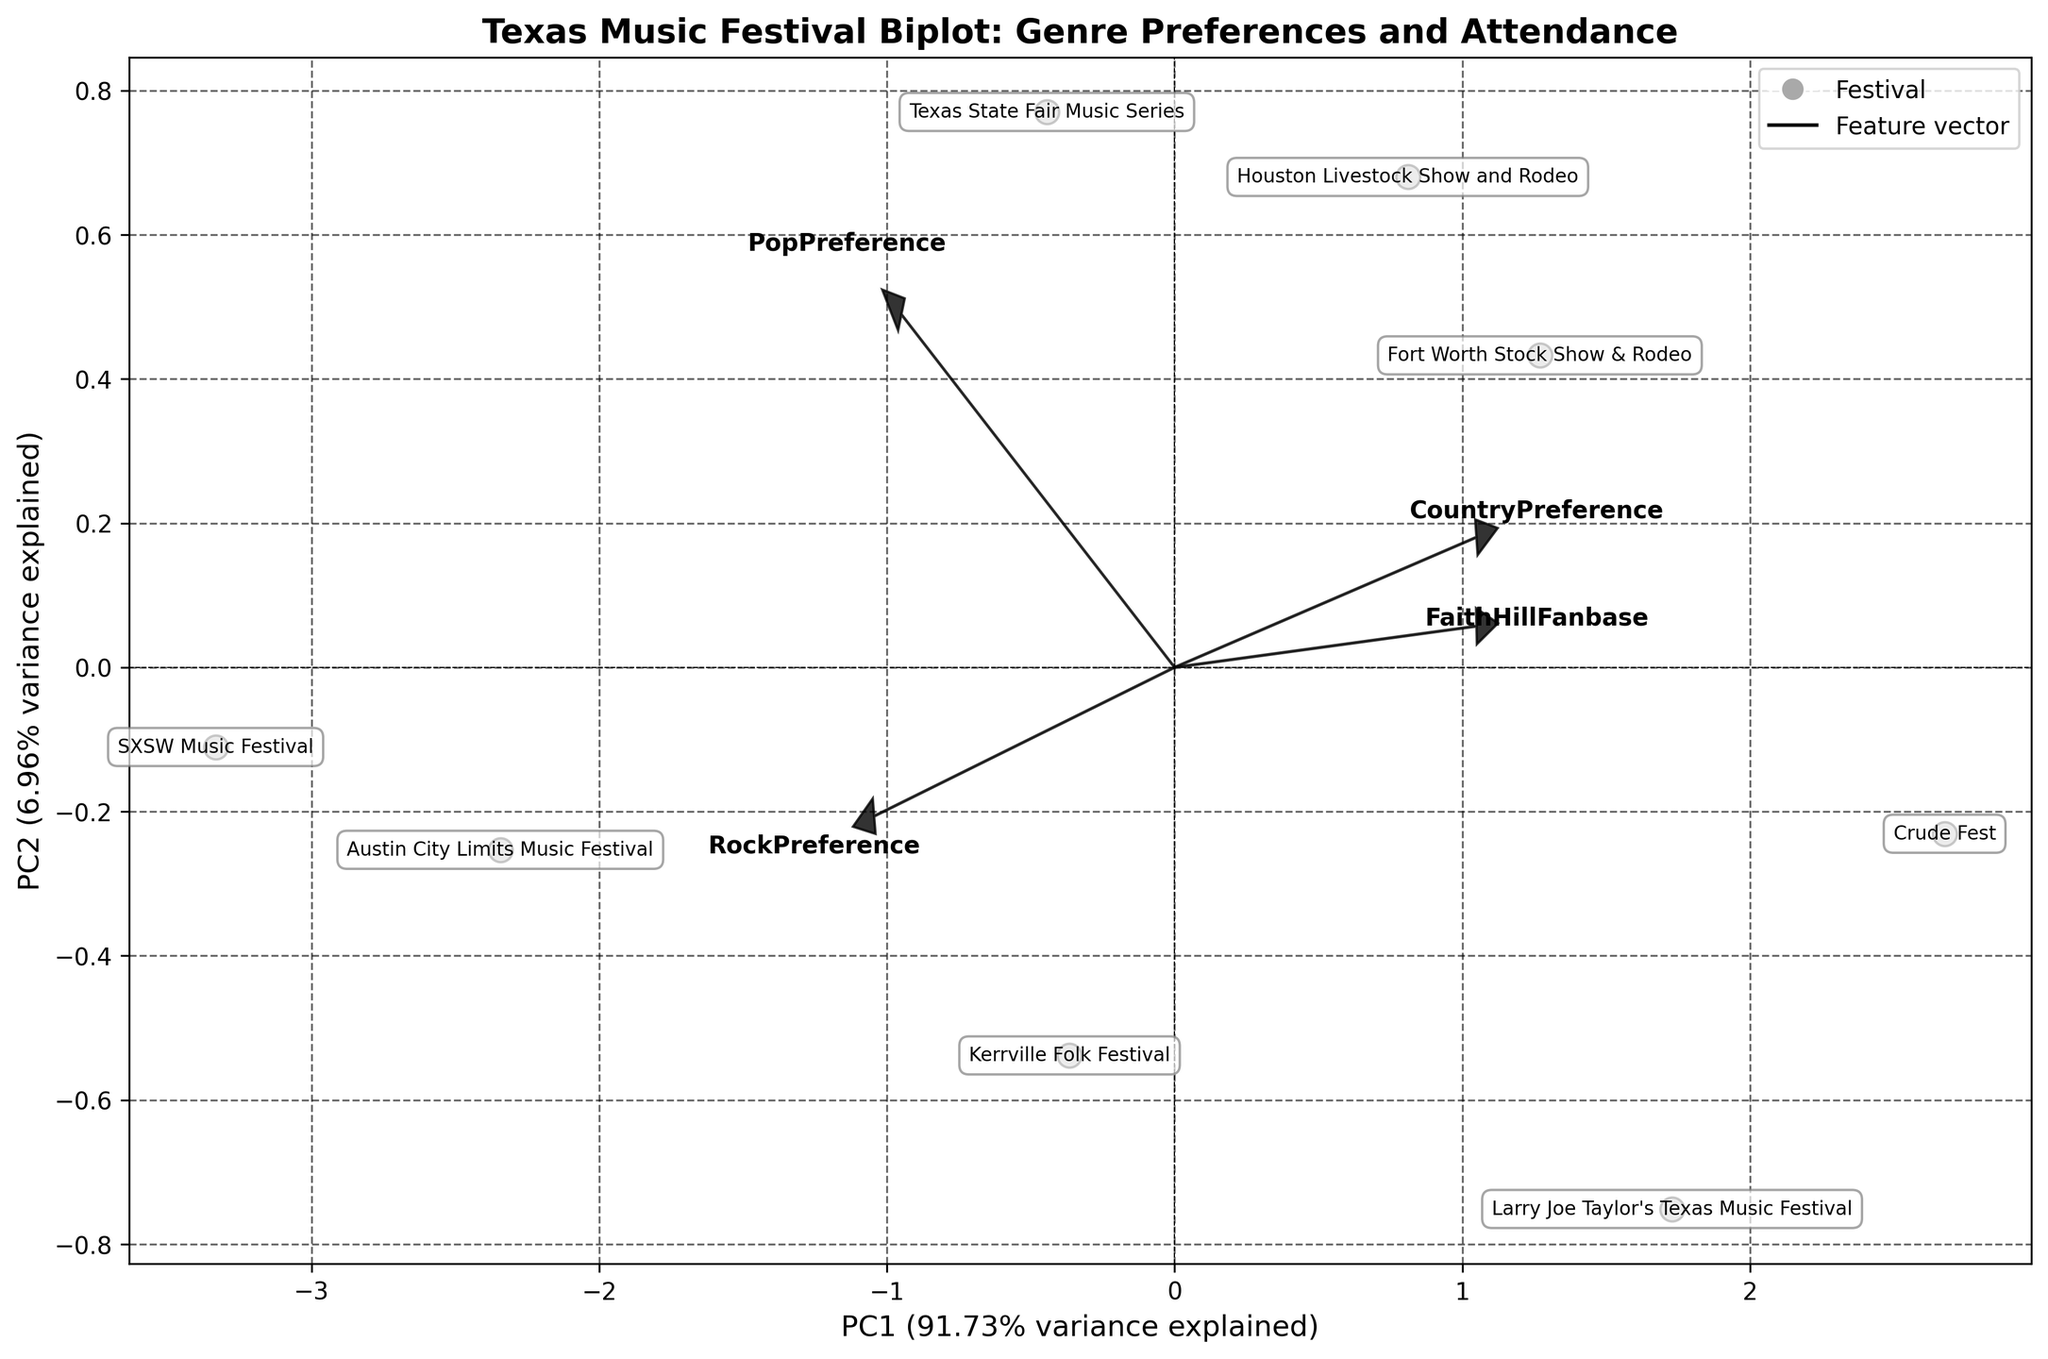What's the title of the figure? The title of the figure can be read directly from the top section of the plot where it is usually displayed prominently in a larger and bolder font.
Answer: Texas Music Festival Biplot: Genre Preferences and Attendance How many data points are there in the biplot? The number of data points is represented by the number of labeled points corresponding to each festival plotted on the graph.
Answer: 8 Which genre preference is most strongly correlated with PC1? The direction and length of the arrows representing the genre preferences give an indication of the correlation strength with the principal components. The arrow with the longest projection on PC1 axis indicates the strongest correlation.
Answer: CountryPreference Which festival has the highest attendance? The festival's attendance can be found by looking at the data points and using the annotations or labels next to these points, referring to the supplementary data table for specific values.
Answer: Houston Livestock Show and Rodeo Compare the FaithHillFanbase between Kerrville Folk Festival and SXSW Music Festival. Which one has a higher value? Using the annotations for each festival in the biplot and referring to the supplementary data table, we find the reference values for FaithHillFanbase for both festivals.
Answer: Kerrville Folk Festival What is the direction of the FaithHillFanbase vector in relation to PC1 and PC2? The direction of the FaithHillFanbase vector can be seen in the biplot where the vector points. By looking at its angle and quadrant, we deduce its direction relative to PC1 and PC2 axes.
Answer: Positive direction towards both PC1 and PC2 If a festival is located in the positive PC1 and negative PC2 quadrant, what can you infer about its genre preferences? By understanding the direction of the vectors and their relationship to PC1 and PC2, if a festival is in the positive PC1 and negative PC2 quadrant, it suggests strong preference for dimensions highly correlated with PC1 and less so for PC2.
Answer: Strong CountryPreference, lower PopPreference and RockPreference Compare the CountryPreference between Fort Worth Stock Show & Rodeo and Crude Fest. Which has a higher preference? By locating the annotated points for Fort Worth Stock Show & Rodeo and Crude Fest and referring to the supplementary data table, we can determine their respective CountryPreference values.
Answer: Crude Fest 